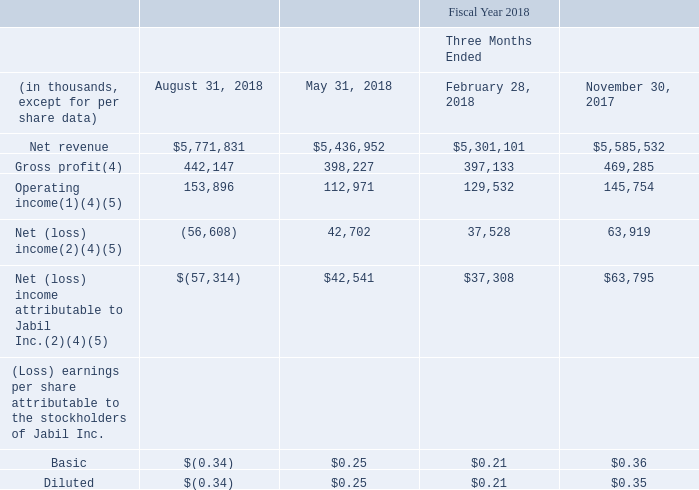Quarterly Results (Unaudited)
The following table sets forth certain unaudited quarterly financial information for the 2019 and 2018 fiscal years. In the opinion of management, this information has been presented on the same basis as the audited consolidated financial statements appearing elsewhere, and all necessary adjustments (consisting primarily of normal recurring accruals) have been included in the amounts stated below to present fairly the unaudited quarterly results when read in conjunction with the audited consolidated financial statements and related notes thereto. The operating results for any quarter are not necessarily indicative of results for any future period.
(1) Includes acquisition and integration charges related to our strategic collaboration with JJMD of $17.6 million, $13.4 million, $12.8 million, $8.9 million and $8.1 million for the three months ended August 31, 2019, May 31, 2019, February 28, 2019, November 30, 2018 and August 31, 2018, respectively.
(2) Includes ($13.3 million), $111.4 million and $30.9 million of income tax (benefit) expense for the three months ended November 30, 2018, August 31, 2018 and February 28, 2018, respectively, related to the Tax Act.
(4) Includes a distressed customer charge of $6.2 million, $18.0 million and $14.7 million during the three months ended August 31, 2019, August 31, 2018 and February 28, 2018, respectively.
(5) Includes $32.4 million of stock-based compensation expense for the modification of certain performancebased restricted stock units and a one-time cash settled award during the three months ended November 30, 2017.
Which months ended quarters does the table show information for Net revenue? August 31, 2018, may 31, 2018, february 28, 2018, november 30, 2017. How much was the income tax (benefit) expense for the three months ended November 30, 2018, August 31, 2018 and February 28, 2018, respectively? ($13.3 million), $111.4 million, $30.9 million. What were the distressed customer charges for  the three months ended August 31, 2019, August 31, 2018 and February 28, 2018, respectively? $6.2 million, $18.0 million, $14.7 million. What was the change in gross profit between May 2018 and August 2018?
Answer scale should be: thousand. 442,147-398,227
Answer: 43920. How many quarters did operating income exceed $150,000 thousand? August 31, 2018
Answer: 1. What was the percentage change in net revenue between the three months ended November 30, 2017 and February 28, 2018?
Answer scale should be: percent. ($5,301,101-$5,585,532)/$5,585,532
Answer: -5.09. 